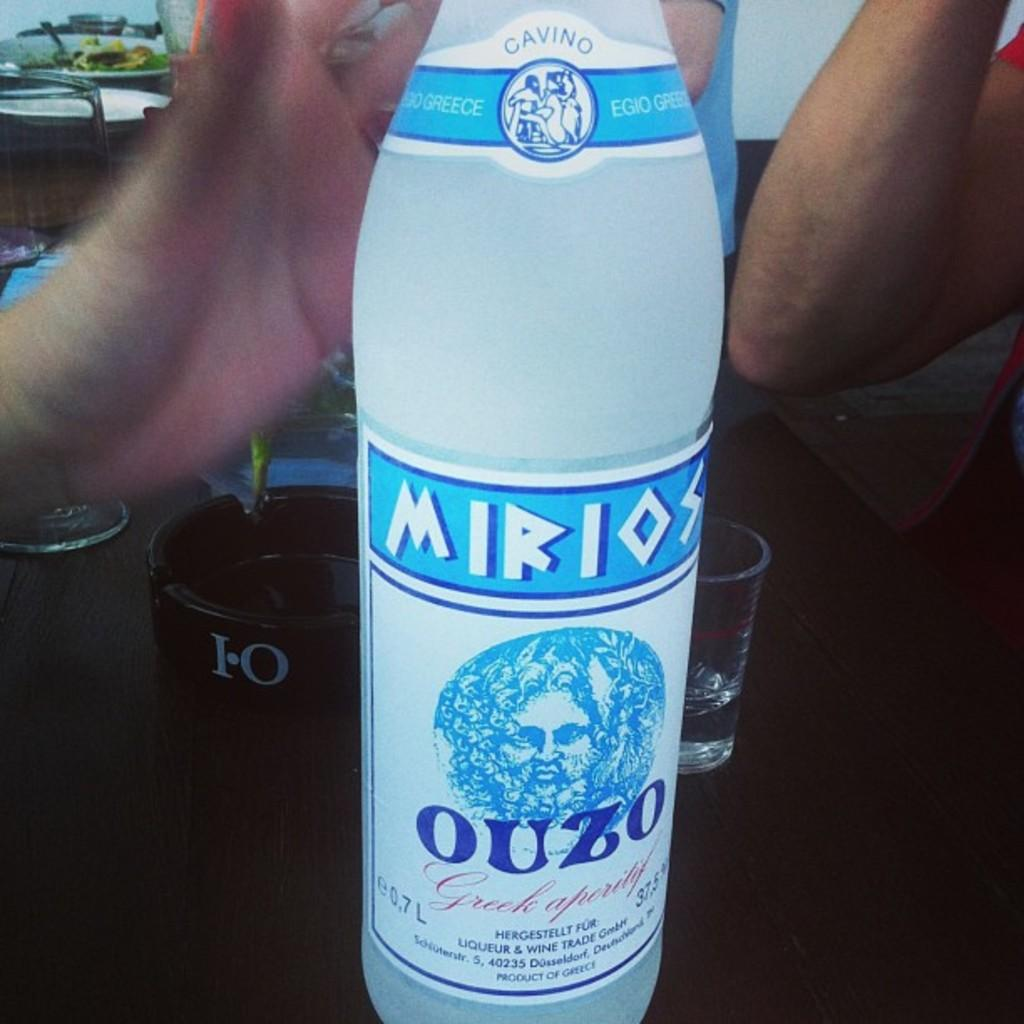<image>
Describe the image concisely. A hand reaches to hold a bottle of Mirios Ouzo. 